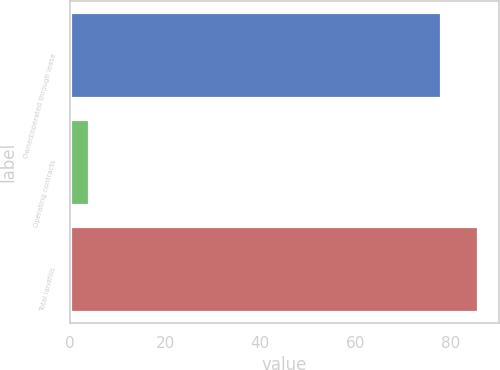<chart> <loc_0><loc_0><loc_500><loc_500><bar_chart><fcel>Owned/operated through lease<fcel>Operating contracts<fcel>Total landfills<nl><fcel>78<fcel>4<fcel>85.8<nl></chart> 